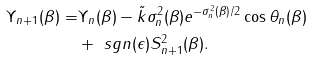<formula> <loc_0><loc_0><loc_500><loc_500>\Upsilon _ { n + 1 } ( \beta ) = & \Upsilon _ { n } ( \beta ) - \tilde { k } \sigma _ { n } ^ { 2 } ( \beta ) e ^ { - \sigma _ { n } ^ { 2 } ( \beta ) / 2 } \cos \theta _ { n } ( \beta ) \\ & + \ s g n ( \epsilon ) S _ { n + 1 } ^ { 2 } ( \beta ) .</formula> 